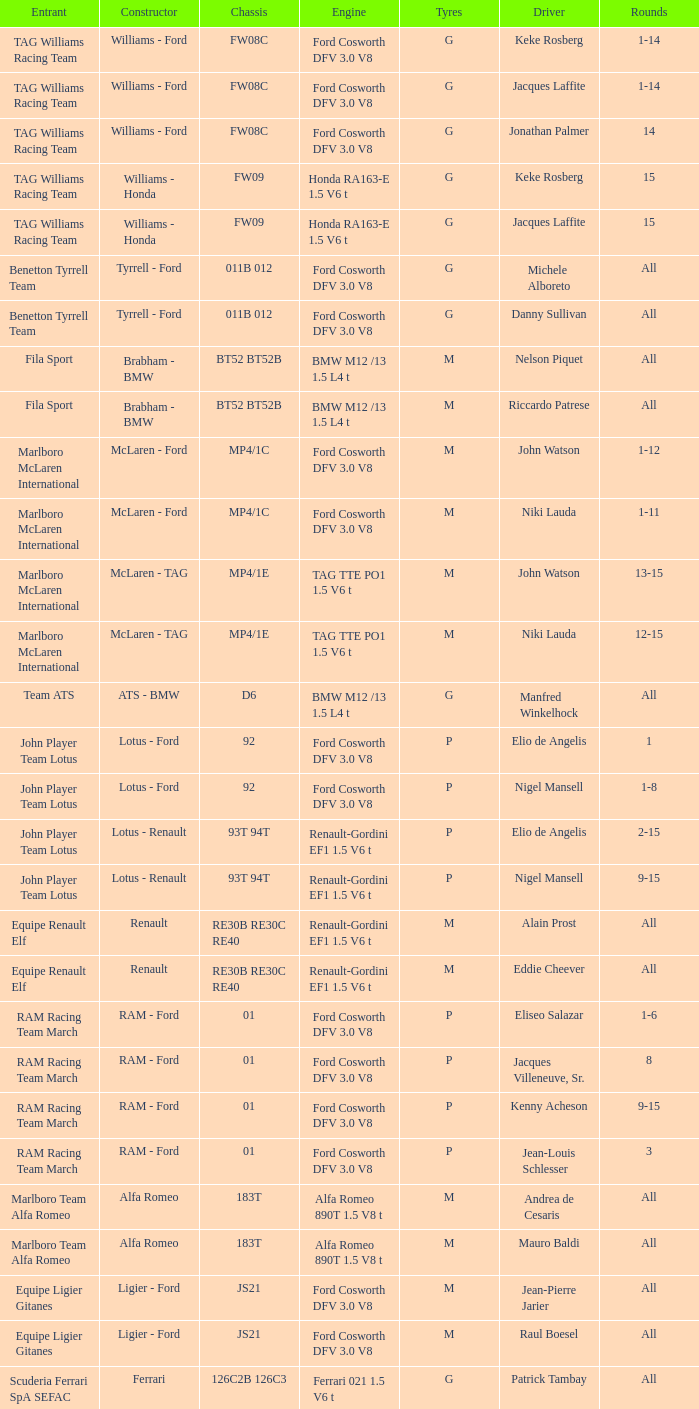Who is the creator for driver piercarlo ghinzani and a ford cosworth dfv Osella - Ford. 